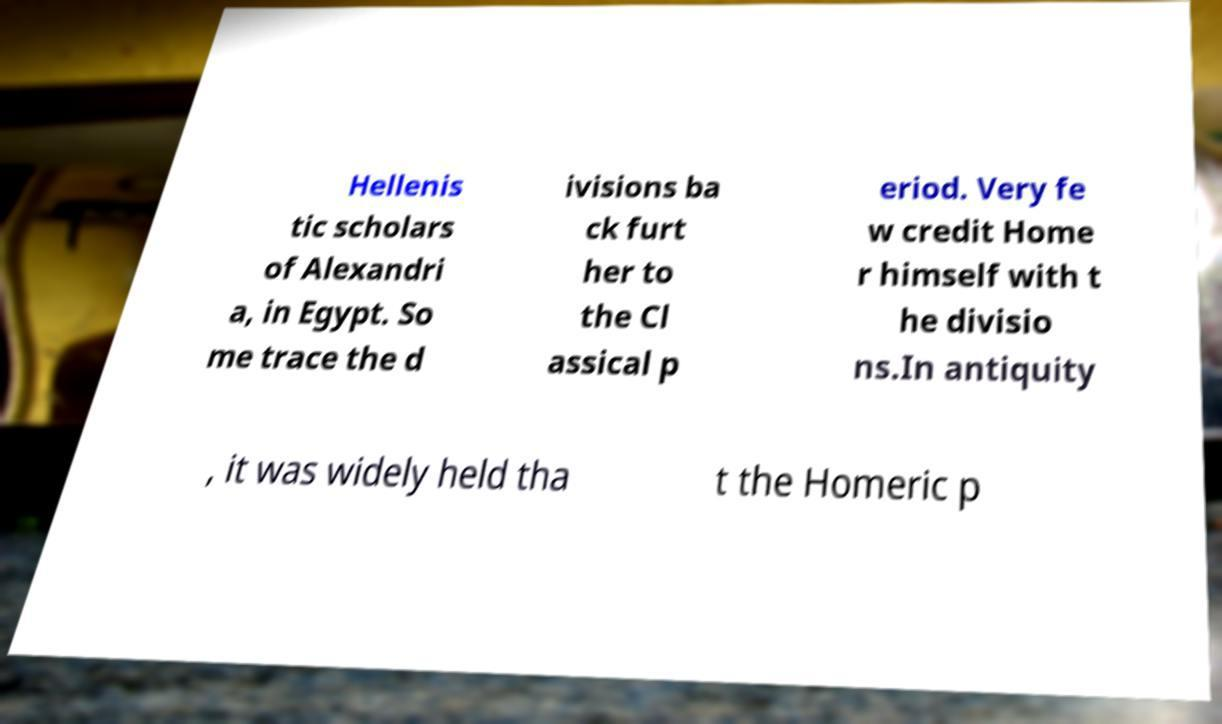Please read and relay the text visible in this image. What does it say? Hellenis tic scholars of Alexandri a, in Egypt. So me trace the d ivisions ba ck furt her to the Cl assical p eriod. Very fe w credit Home r himself with t he divisio ns.In antiquity , it was widely held tha t the Homeric p 